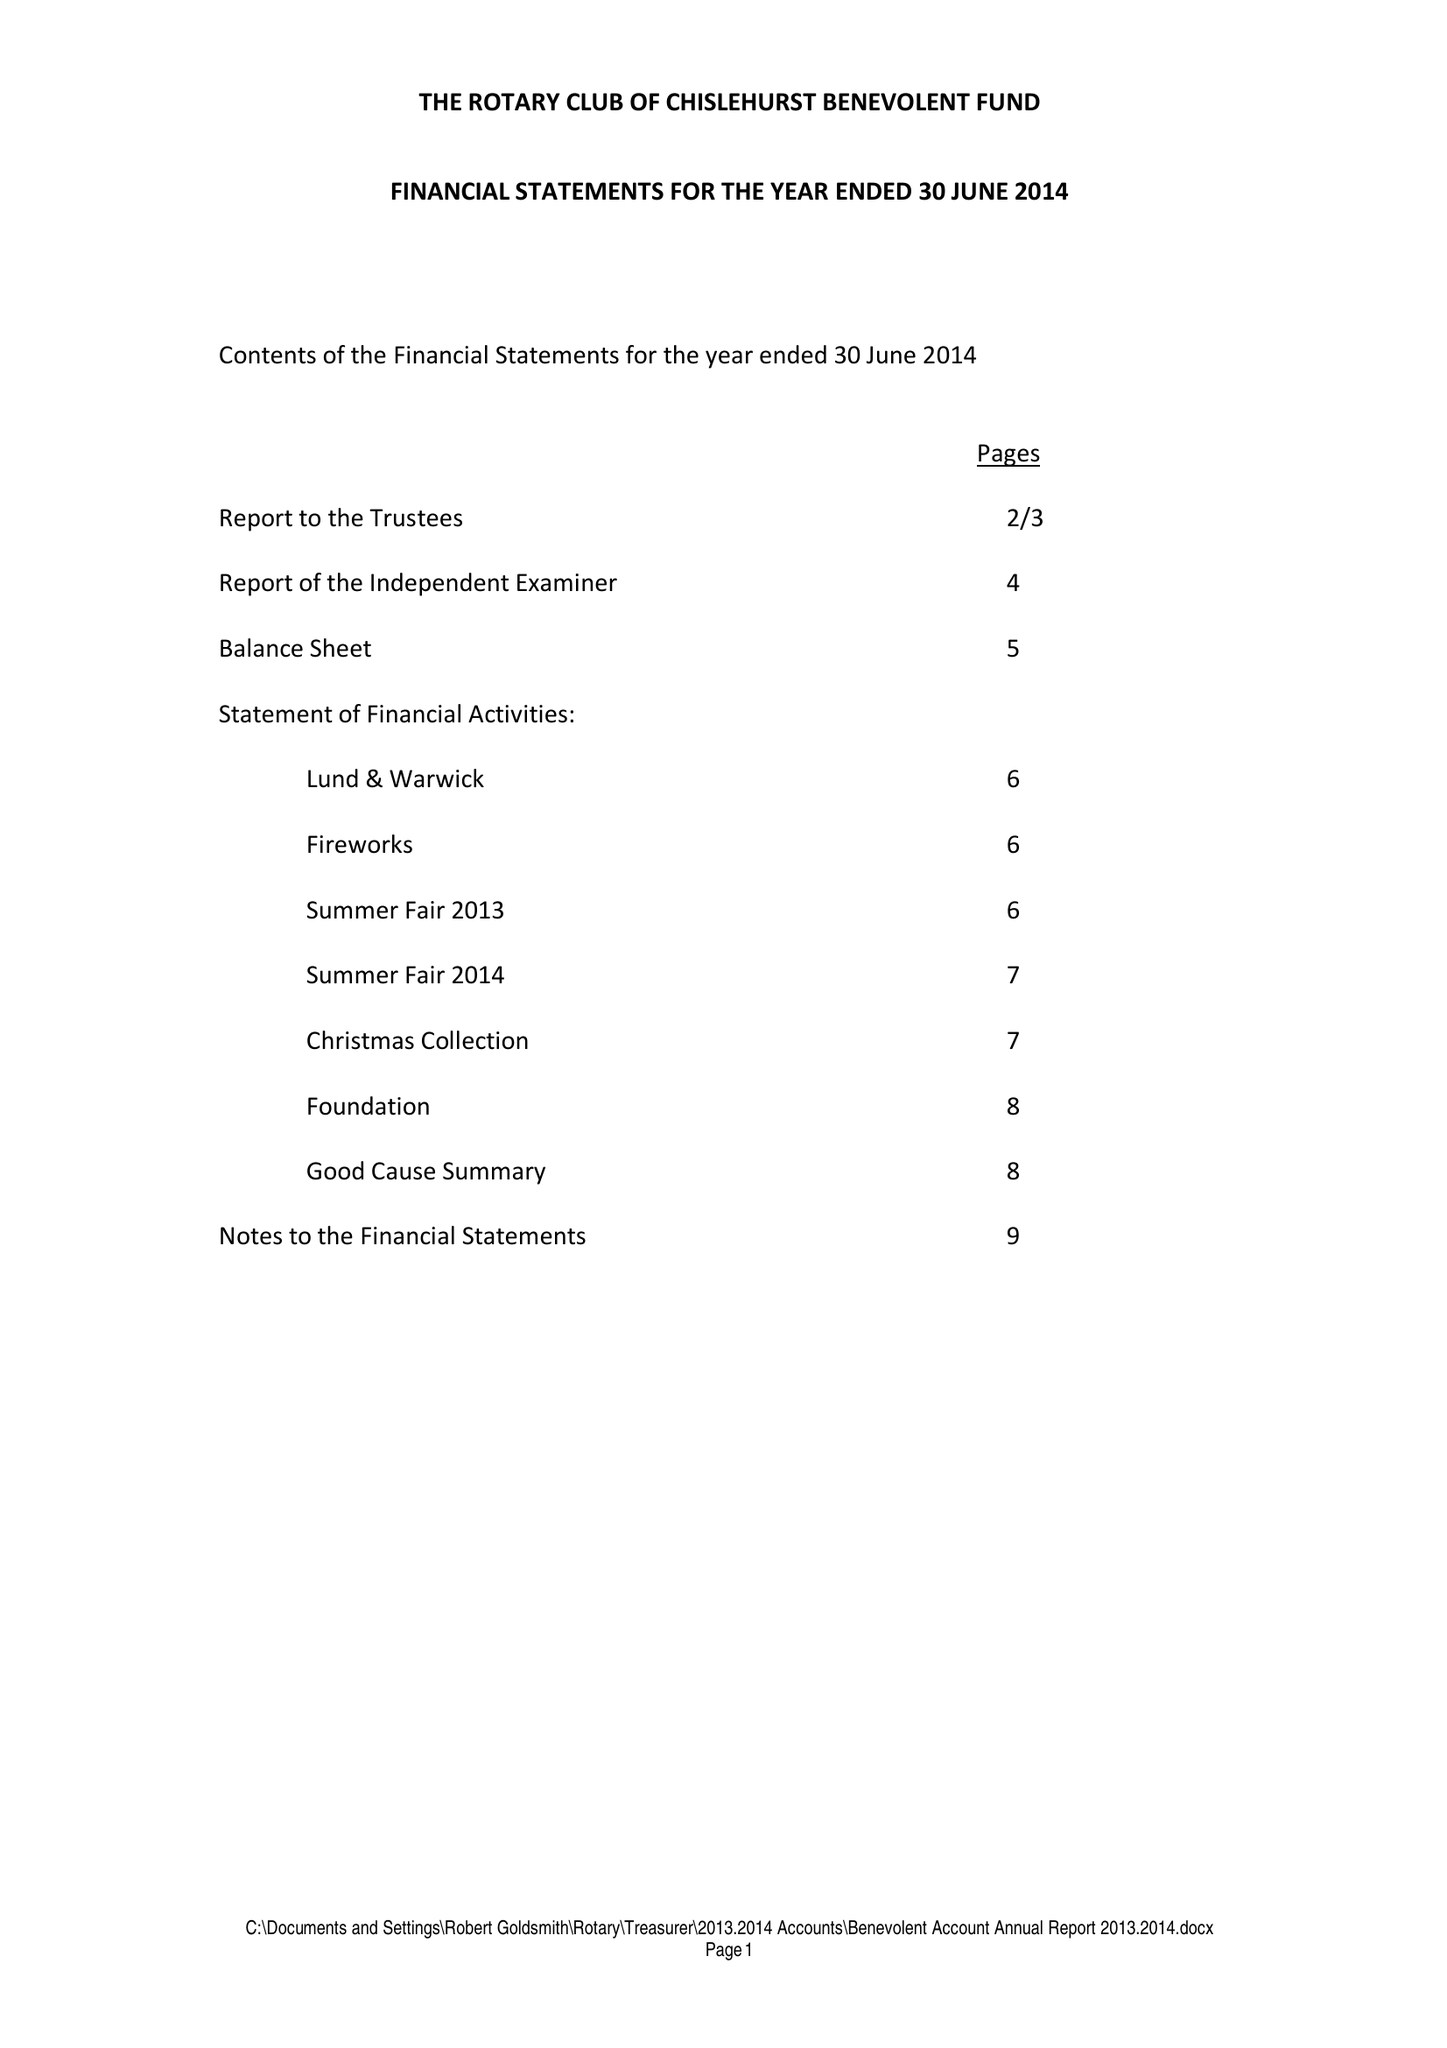What is the value for the charity_name?
Answer the question using a single word or phrase. The Rotary Club Of Chislehurst Benevolent Fund 